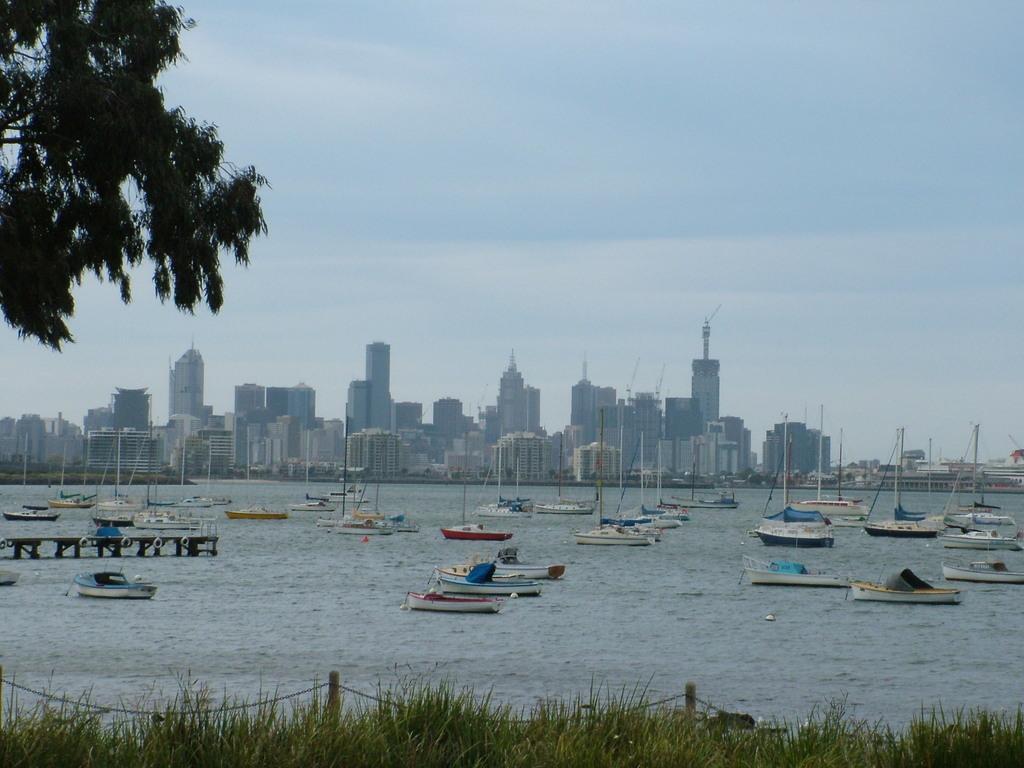Please provide a concise description of this image. In this image, I can see the boats on the water. This is the grass. I can see the buildings and skyscrapers. This looks like a tree with branches and leaves. I think this is the wooden bridge. 